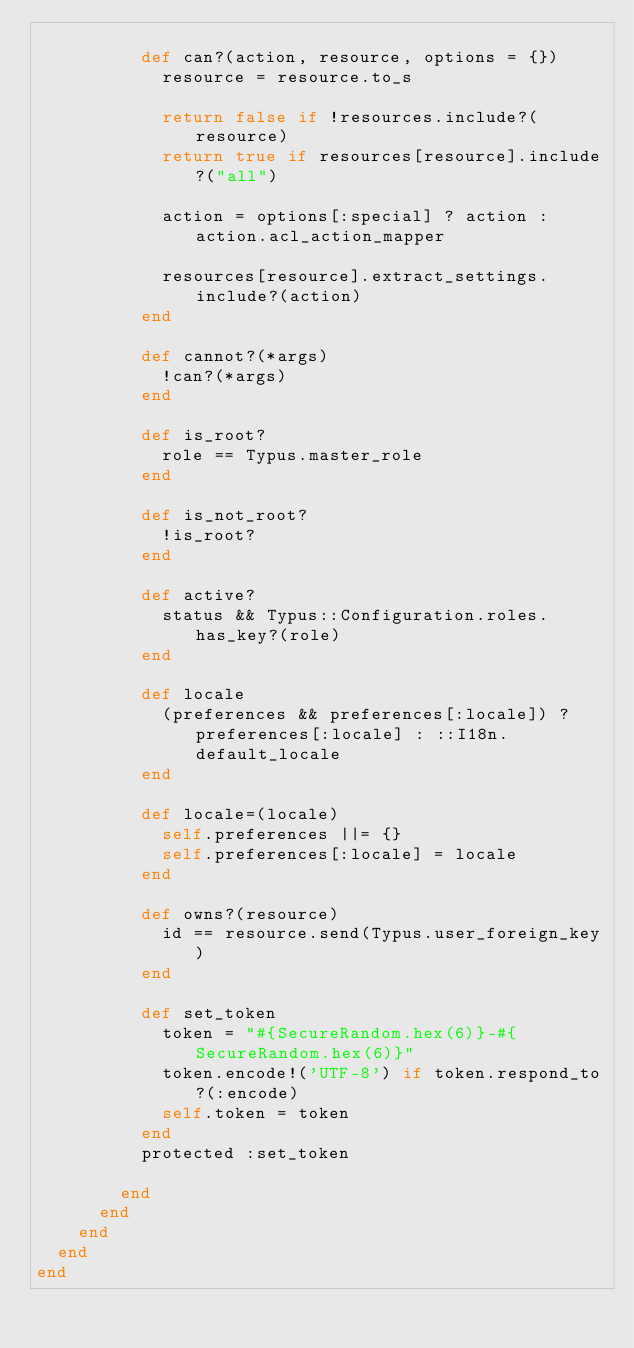<code> <loc_0><loc_0><loc_500><loc_500><_Ruby_>
          def can?(action, resource, options = {})
            resource = resource.to_s

            return false if !resources.include?(resource)
            return true if resources[resource].include?("all")

            action = options[:special] ? action : action.acl_action_mapper

            resources[resource].extract_settings.include?(action)
          end

          def cannot?(*args)
            !can?(*args)
          end

          def is_root?
            role == Typus.master_role
          end

          def is_not_root?
            !is_root?
          end

          def active?
            status && Typus::Configuration.roles.has_key?(role)
          end

          def locale
            (preferences && preferences[:locale]) ? preferences[:locale] : ::I18n.default_locale
          end

          def locale=(locale)
            self.preferences ||= {}
            self.preferences[:locale] = locale
          end

          def owns?(resource)
            id == resource.send(Typus.user_foreign_key)
          end

          def set_token
            token = "#{SecureRandom.hex(6)}-#{SecureRandom.hex(6)}"
            token.encode!('UTF-8') if token.respond_to?(:encode)
            self.token = token
          end
          protected :set_token

        end
      end
    end
  end
end
</code> 